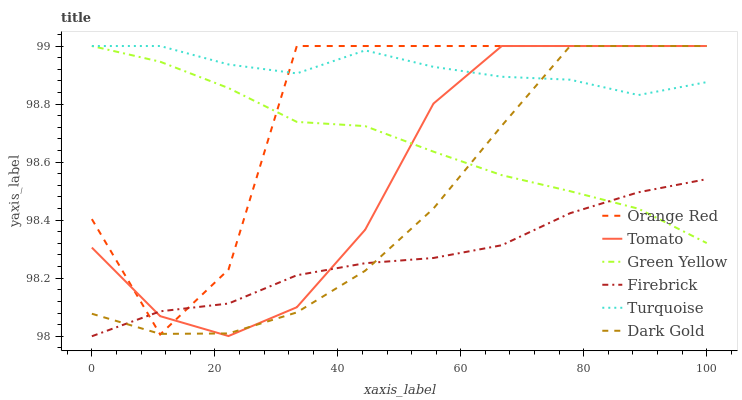Does Firebrick have the minimum area under the curve?
Answer yes or no. Yes. Does Turquoise have the maximum area under the curve?
Answer yes or no. Yes. Does Dark Gold have the minimum area under the curve?
Answer yes or no. No. Does Dark Gold have the maximum area under the curve?
Answer yes or no. No. Is Green Yellow the smoothest?
Answer yes or no. Yes. Is Orange Red the roughest?
Answer yes or no. Yes. Is Turquoise the smoothest?
Answer yes or no. No. Is Turquoise the roughest?
Answer yes or no. No. Does Firebrick have the lowest value?
Answer yes or no. Yes. Does Dark Gold have the lowest value?
Answer yes or no. No. Does Orange Red have the highest value?
Answer yes or no. Yes. Does Firebrick have the highest value?
Answer yes or no. No. Is Firebrick less than Turquoise?
Answer yes or no. Yes. Is Turquoise greater than Firebrick?
Answer yes or no. Yes. Does Orange Red intersect Firebrick?
Answer yes or no. Yes. Is Orange Red less than Firebrick?
Answer yes or no. No. Is Orange Red greater than Firebrick?
Answer yes or no. No. Does Firebrick intersect Turquoise?
Answer yes or no. No. 